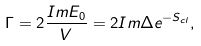<formula> <loc_0><loc_0><loc_500><loc_500>\Gamma = 2 \frac { I m E _ { 0 } } { V } = 2 I m \Delta e ^ { - S _ { c l } } ,</formula> 